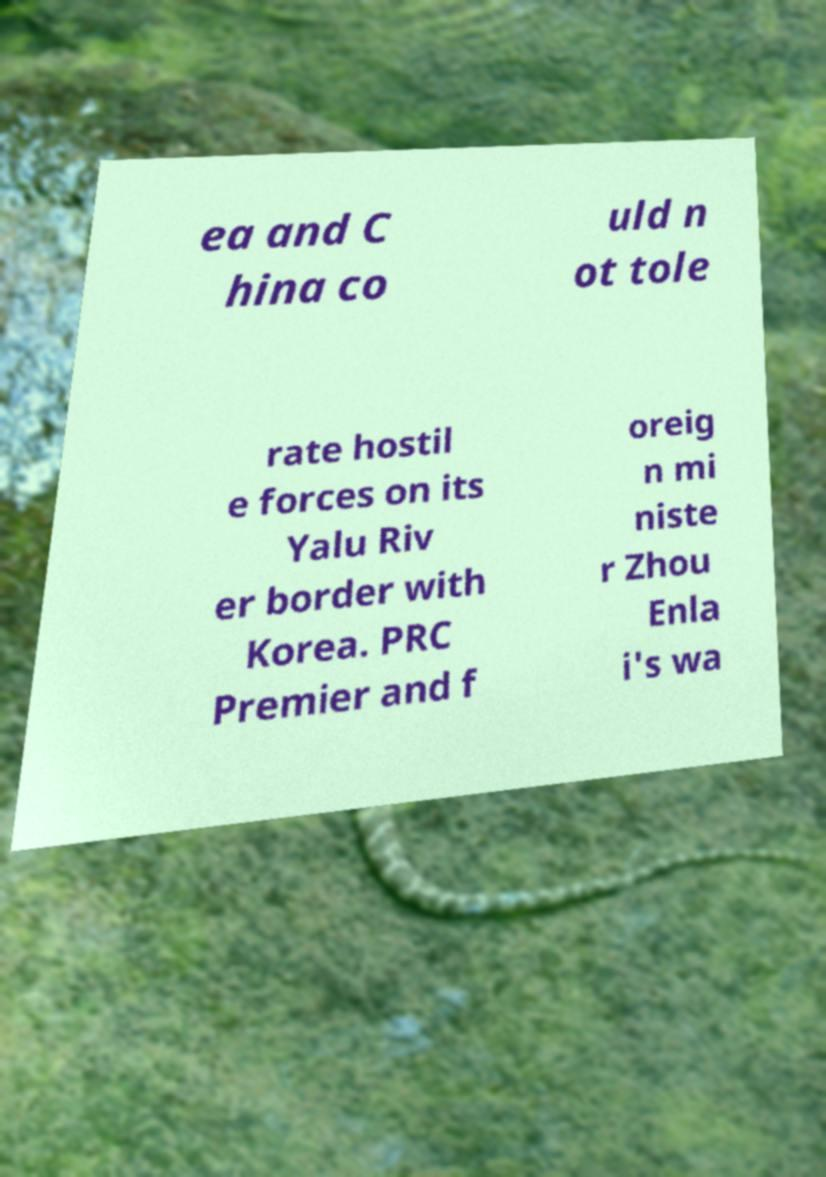Can you read and provide the text displayed in the image?This photo seems to have some interesting text. Can you extract and type it out for me? ea and C hina co uld n ot tole rate hostil e forces on its Yalu Riv er border with Korea. PRC Premier and f oreig n mi niste r Zhou Enla i's wa 